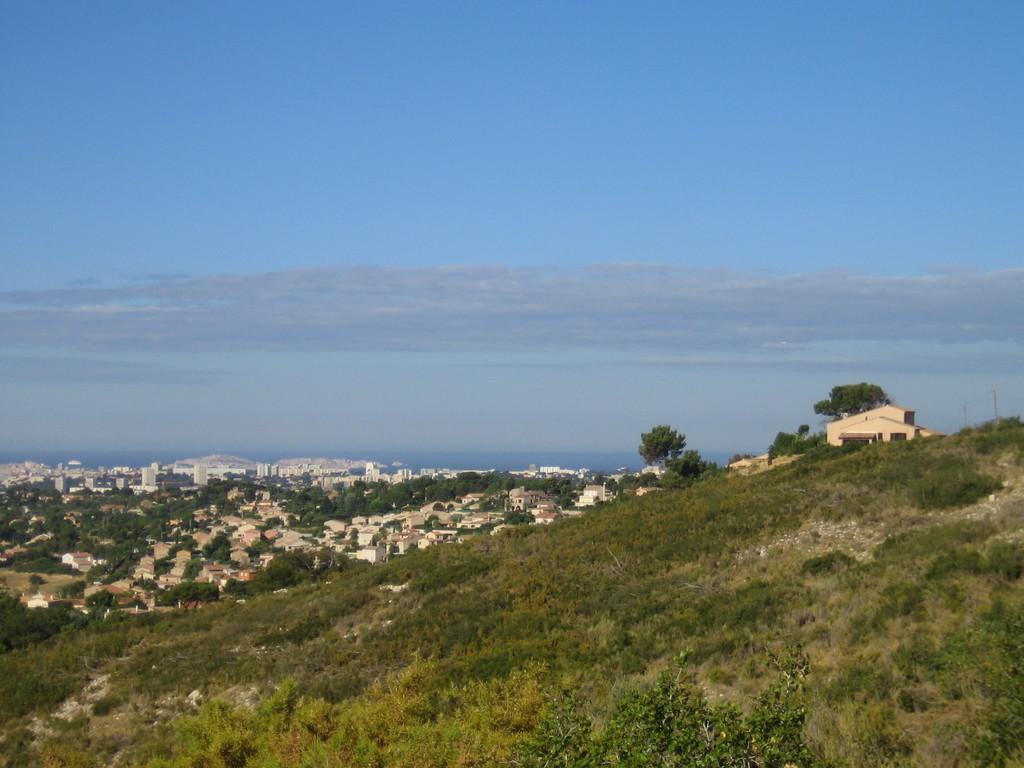What is located at the bottom of the image? There are plants, grass, and buildings on a mountain at the bottom of the image. What type of vegetation is present at the bottom of the image? There is grass at the bottom of the image. What can be seen in the background of the image? There are buildings, trees, and clouds in the sky in the background of the image. Where is the sink located in the image? There is no sink present in the image. What type of stage is visible in the image? There is no stage present in the image. 